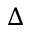Convert formula to latex. <formula><loc_0><loc_0><loc_500><loc_500>\Delta</formula> 